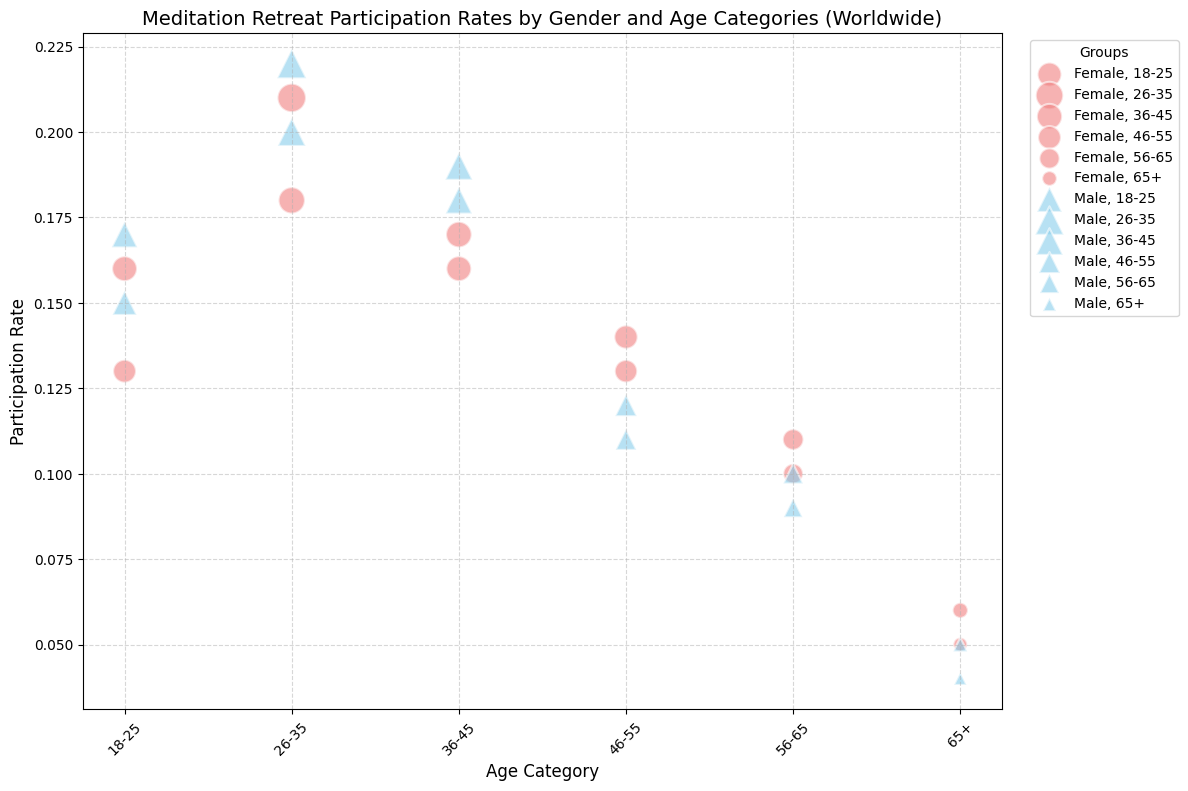Which gender and age category has the highest participation rate? To find the gender and age category with the highest participation rate, observe the bubbles positioned furthest along the vertical axis (Participation Rate). The highest point indicates the maximum rate.
Answer: Male, 26-35 What is the participation rate difference between males and females in the 26-35 age category? Locate the bubbles corresponding to males and females within the 26-35 age category. Subtract the female participation rate from the male participation rate.
Answer: 0.01 Which gender has the largest bubble size in the 18-25 age category, and what does it represent? Compare the male and female bubbles in the 18-25 age category. The size of the bubble represents the count of participants. Identify the largest bubble.
Answer: Male, representing the participant count Between the 36-45 and 46-55 age categories, which gender shows a greater decrease in participation rate? Identify the participation rates for both genders in the 36-45 and 46-55 age categories. Calculate the difference in participation rates for each gender and compare them.
Answer: Male For the age category 65+, how does the female participation rate compare to the male participation rate? Examine the bubbles for males and females in the 65+ age category along the vertical axis (Participation Rate). Compare these rates directly.
Answer: Female has a higher participation rate What is the average participation rate for females across all age categories? Extract the participation rates for females in each age category. Sum these rates and divide by the number of categories to find the average.
Answer: 0.125 Do larger bubbles correspond to higher participation rates? Compare the sizes of the bubbles with their respective positions along the participation rate axis. Determine if larger bubbles consistently align with higher rates.
Answer: Not necessarily How does the participation count for males aged 56-65 compare to females aged 56-65? Look at the bubble sizes for males and females in the 56-65 category. The size correlates with participant count.
Answer: Males have a lower count Are there any age categories where females have a higher participation rate than males? Compare the participation rates along the vertical axis for both genders across all age categories. Identify any instances where females are higher.
Answer: Yes, 46-55 and 65+ 